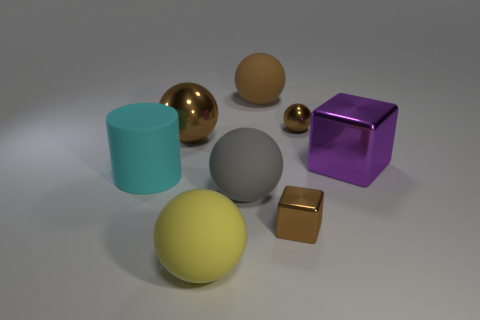Is the large gray thing made of the same material as the tiny sphere?
Make the answer very short. No. What color is the big ball in front of the metal cube to the left of the big shiny object right of the small metallic ball?
Give a very brief answer. Yellow. Are the tiny brown thing that is behind the cylinder and the cylinder made of the same material?
Offer a very short reply. No. Is there a rubber cylinder that has the same color as the tiny ball?
Provide a short and direct response. No. Are any big red cylinders visible?
Your answer should be compact. No. Is the size of the brown object that is in front of the purple shiny block the same as the large cyan rubber object?
Ensure brevity in your answer.  No. Are there fewer large yellow matte balls than small blue rubber things?
Your answer should be compact. No. There is a large matte object behind the large brown object in front of the matte ball behind the large cyan thing; what is its shape?
Make the answer very short. Sphere. Is there a large cylinder made of the same material as the gray ball?
Offer a terse response. Yes. Does the block left of the small brown shiny ball have the same color as the shiny cube that is behind the large cyan rubber cylinder?
Make the answer very short. No. 